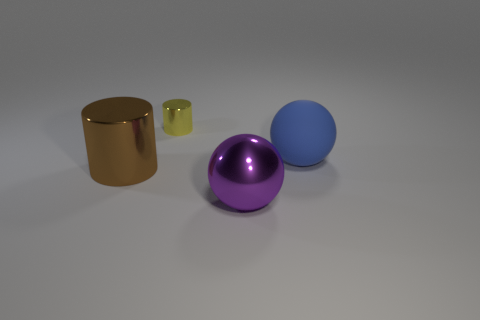Add 3 tiny green rubber blocks. How many objects exist? 7 Subtract all tiny red cylinders. Subtract all cylinders. How many objects are left? 2 Add 3 purple metallic spheres. How many purple metallic spheres are left? 4 Add 3 matte balls. How many matte balls exist? 4 Subtract 1 brown cylinders. How many objects are left? 3 